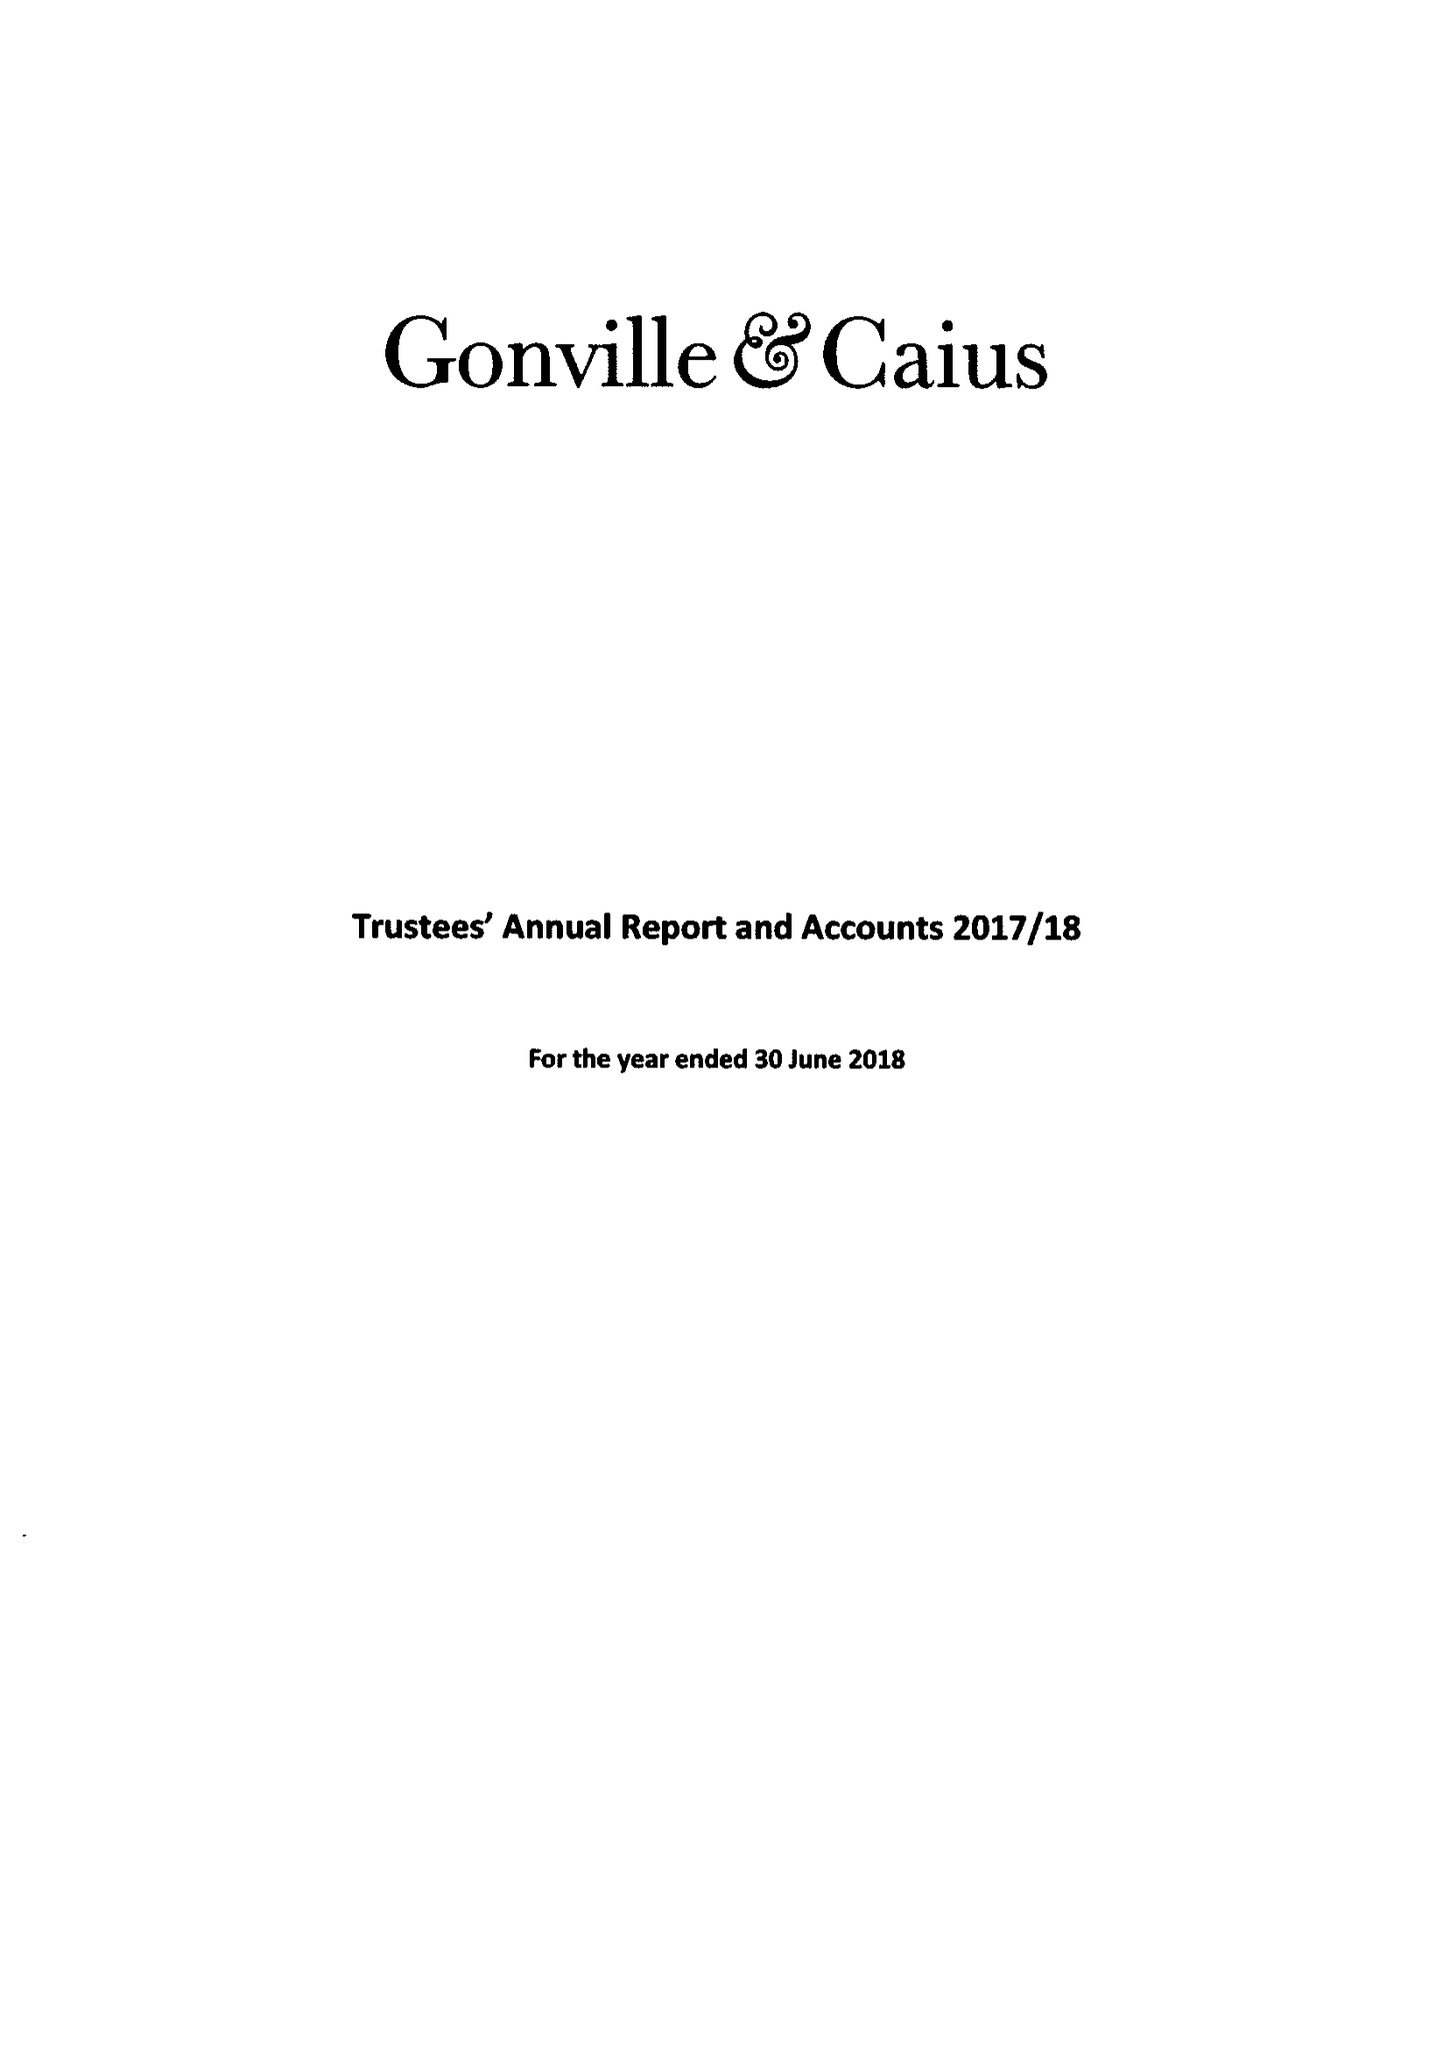What is the value for the report_date?
Answer the question using a single word or phrase. 2018-06-30 